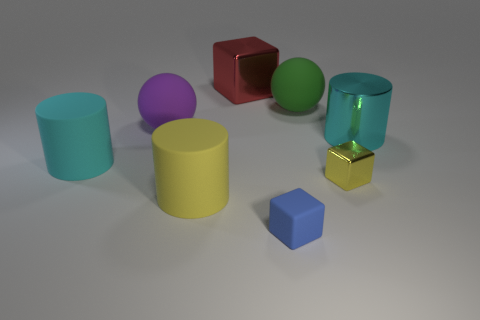Add 1 cyan rubber things. How many objects exist? 9 Subtract all balls. How many objects are left? 6 Subtract 0 purple cylinders. How many objects are left? 8 Subtract all tiny yellow matte cubes. Subtract all large red blocks. How many objects are left? 7 Add 2 tiny rubber things. How many tiny rubber things are left? 3 Add 4 big cyan objects. How many big cyan objects exist? 6 